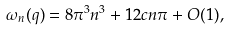<formula> <loc_0><loc_0><loc_500><loc_500>\omega _ { n } ( q ) = 8 \pi ^ { 3 } n ^ { 3 } + 1 2 c n \pi + O ( 1 ) ,</formula> 